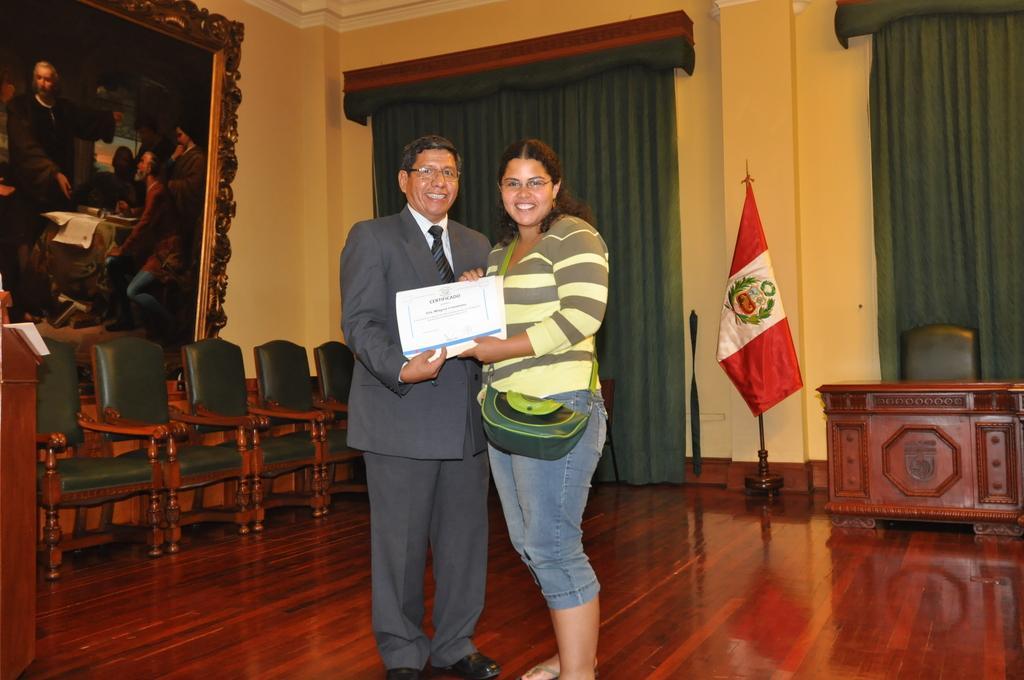How would you summarize this image in a sentence or two? Image is clicked in a room. There are curtains on the backside, there is a flag, table and chair on the right side. There are chairs on the left side too. There is a photo frame on the wall on the top left corner. There are two people in this image, one is man and the other one is woman. Both of them holding a paper. 